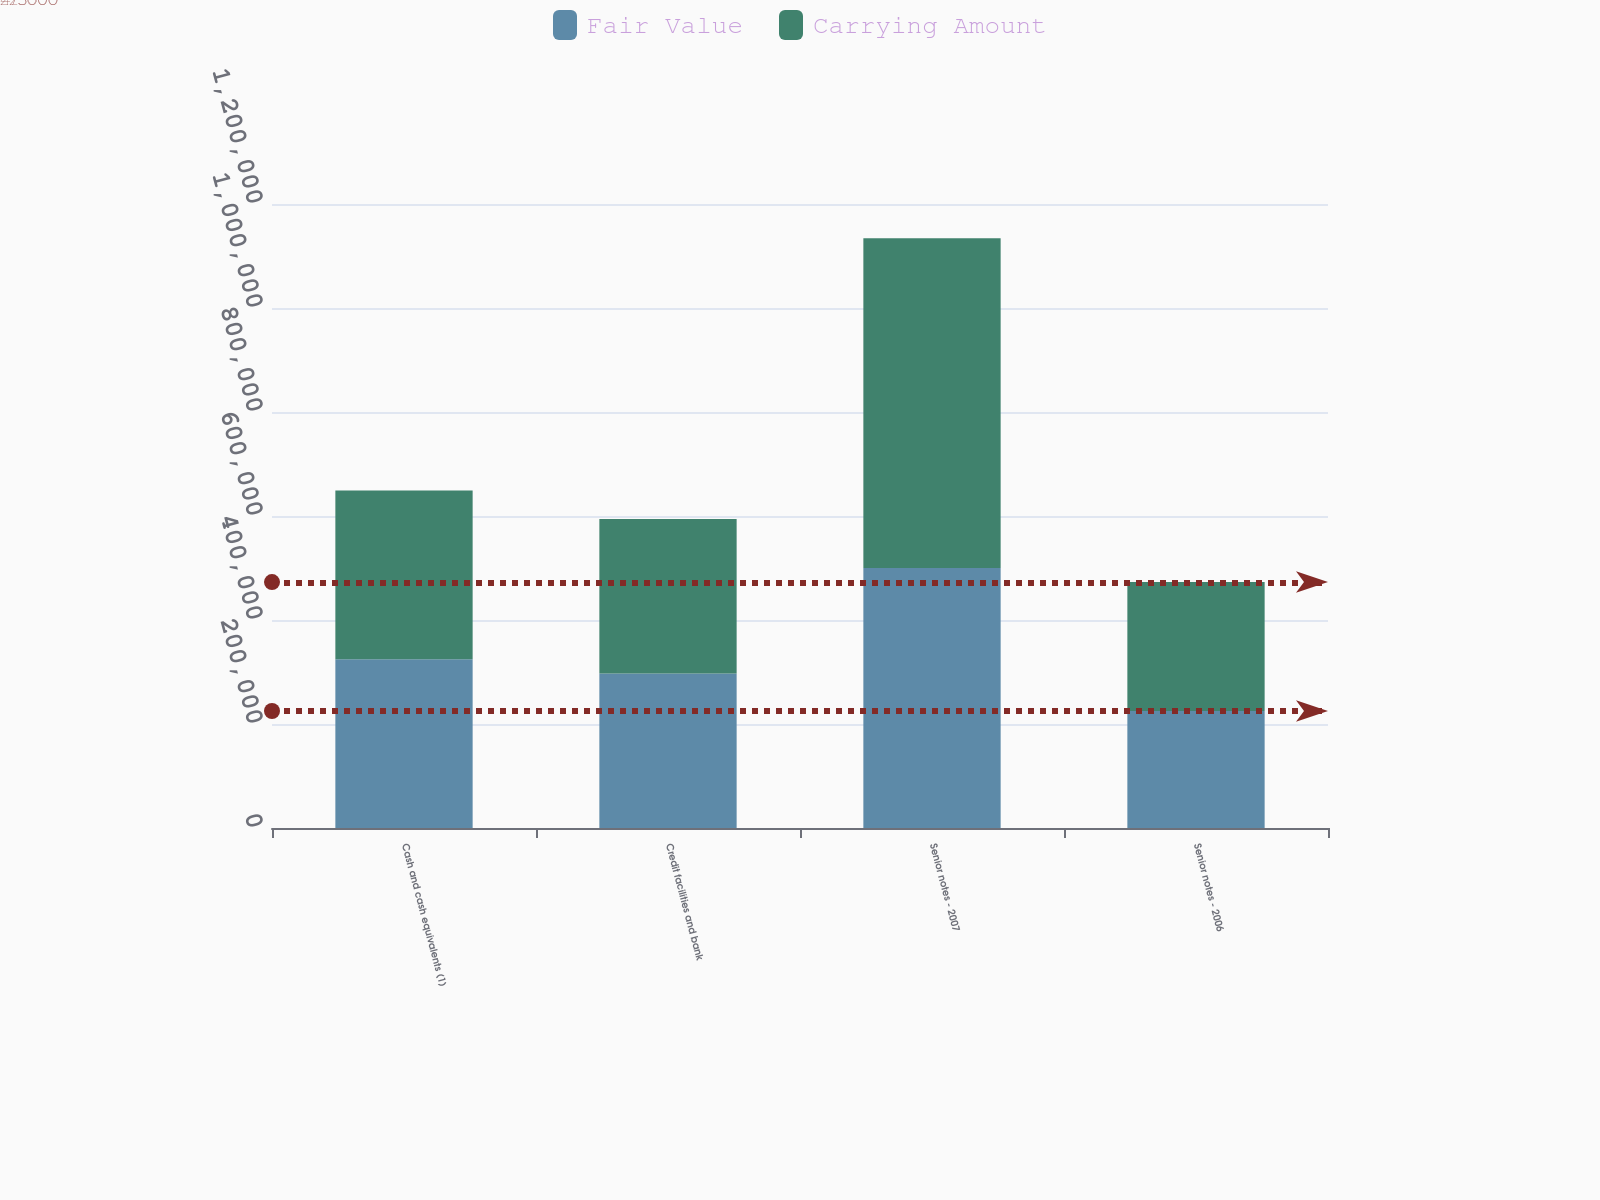Convert chart. <chart><loc_0><loc_0><loc_500><loc_500><stacked_bar_chart><ecel><fcel>Cash and cash equivalents (1)<fcel>Credit facilities and bank<fcel>Senior notes - 2007<fcel>Senior notes - 2006<nl><fcel>Fair Value<fcel>324422<fcel>297147<fcel>500000<fcel>225000<nl><fcel>Carrying Amount<fcel>324422<fcel>297147<fcel>634000<fcel>248000<nl></chart> 